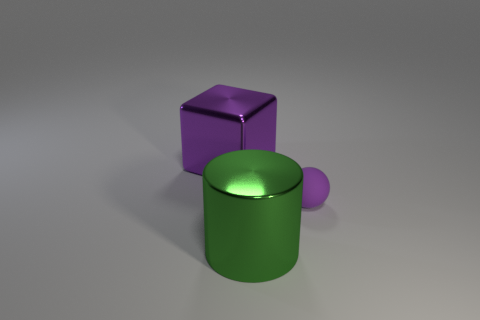Can you describe the lighting and shadows in the scene? In the image, there is a single diffuse light source that appears to be above and slightly to the right of the objects, as evidenced by the soft shadows cast to the lower left of the objects. The lighting provides moderate contrast and helps define the shape of the objects, emphasizing their three-dimensionality without creating harsh shadows. 